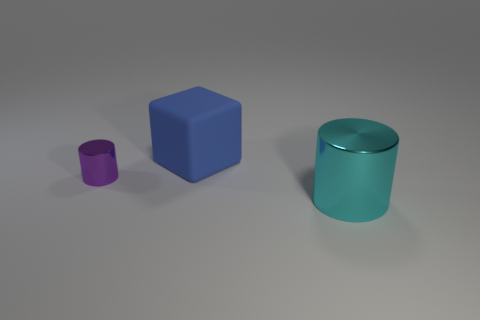What number of things are to the left of the large blue cube?
Make the answer very short. 1. Are there the same number of small metallic cylinders that are on the left side of the matte block and purple metal cylinders in front of the small purple metallic cylinder?
Make the answer very short. No. Is the shape of the large object on the right side of the big matte object the same as  the matte thing?
Make the answer very short. No. Is there anything else that has the same material as the small purple object?
Your answer should be very brief. Yes. There is a purple metal cylinder; is it the same size as the thing behind the purple metallic cylinder?
Provide a succinct answer. No. What number of other objects are there of the same color as the large cylinder?
Ensure brevity in your answer.  0. Are there any big rubber objects behind the large cyan shiny thing?
Give a very brief answer. Yes. What number of objects are large gray spheres or metallic cylinders left of the cyan thing?
Your answer should be very brief. 1. There is a thing that is left of the large blue block; are there any purple cylinders behind it?
Your answer should be compact. No. There is a metal thing in front of the thing that is to the left of the big object to the left of the large cyan object; what shape is it?
Keep it short and to the point. Cylinder. 